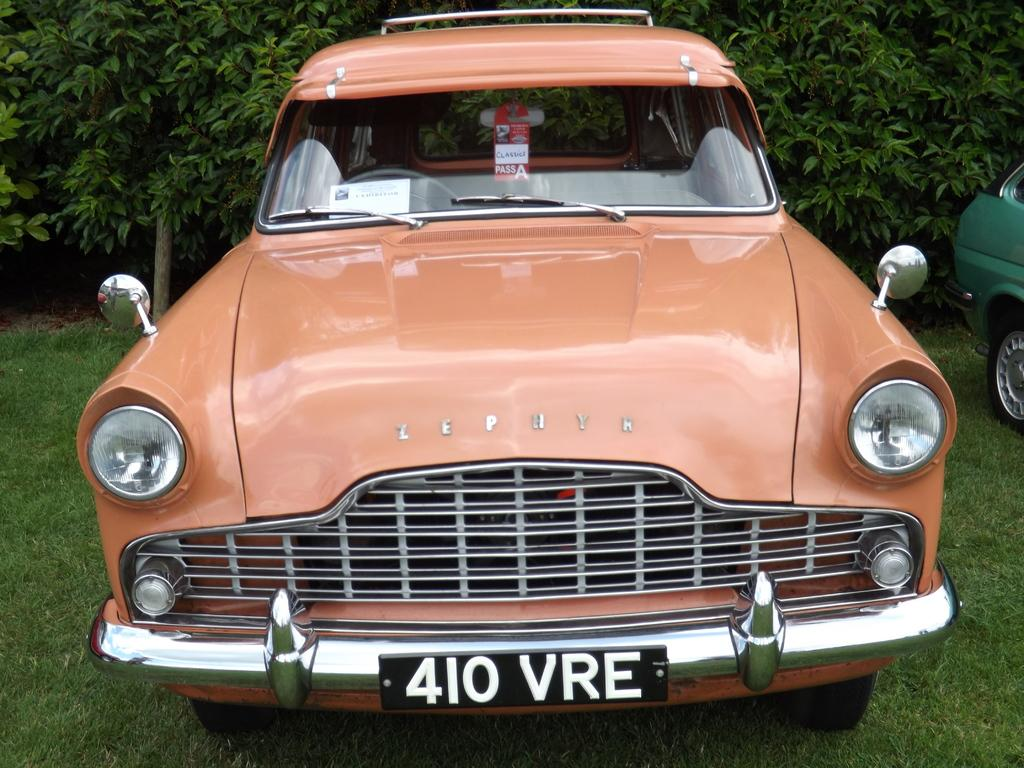What type of vehicles are on the grass in the image? There are cars on the surface of the grass in the image. What can be seen in the distance behind the cars? There are trees visible in the background of the image. What type of seed is the coach holding in the image? There is no seed or coach present in the image; it only features cars on the grass and trees in the background. 